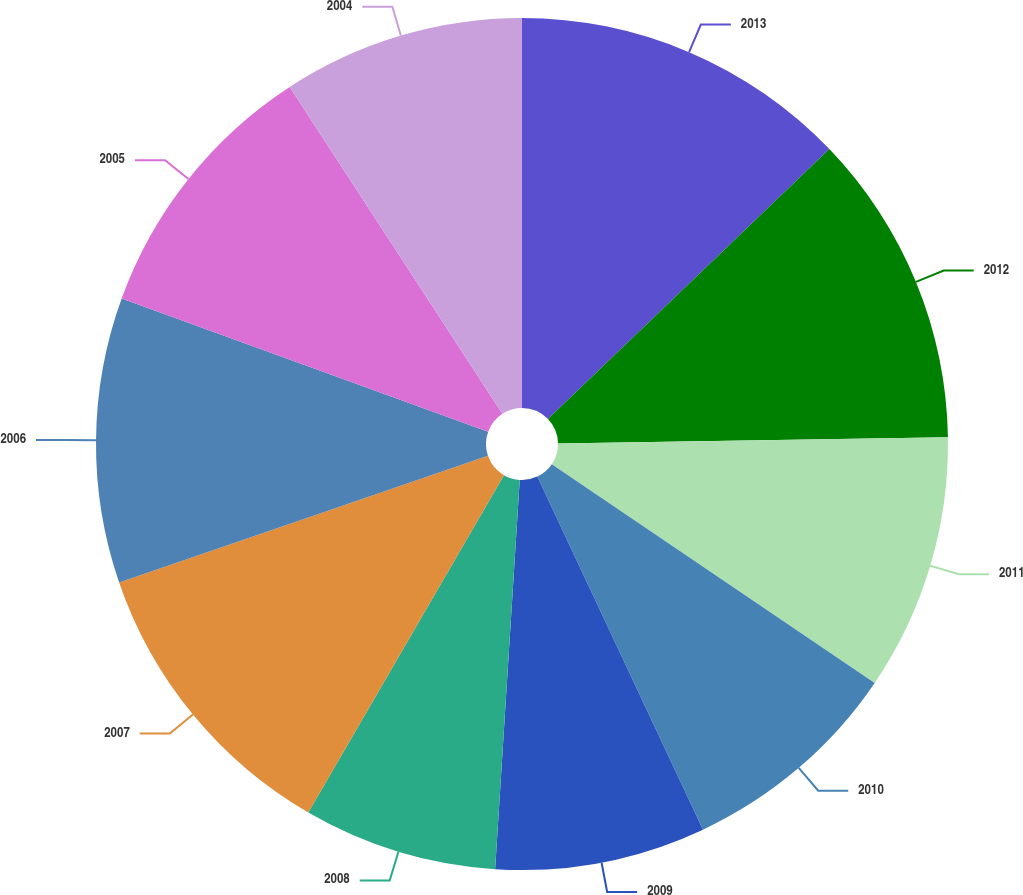Convert chart. <chart><loc_0><loc_0><loc_500><loc_500><pie_chart><fcel>2013<fcel>2012<fcel>2011<fcel>2010<fcel>2009<fcel>2008<fcel>2007<fcel>2006<fcel>2005<fcel>2004<nl><fcel>12.83%<fcel>11.92%<fcel>9.73%<fcel>8.54%<fcel>7.99%<fcel>7.36%<fcel>11.37%<fcel>10.82%<fcel>10.27%<fcel>9.18%<nl></chart> 